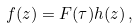<formula> <loc_0><loc_0><loc_500><loc_500>f ( z ) = F ( \tau ) h ( z ) \, ,</formula> 